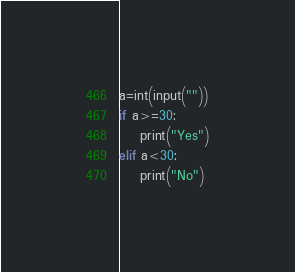Convert code to text. <code><loc_0><loc_0><loc_500><loc_500><_Python_>a=int(input(""))
if a>=30:
    print("Yes")
elif a<30:
    print("No")</code> 